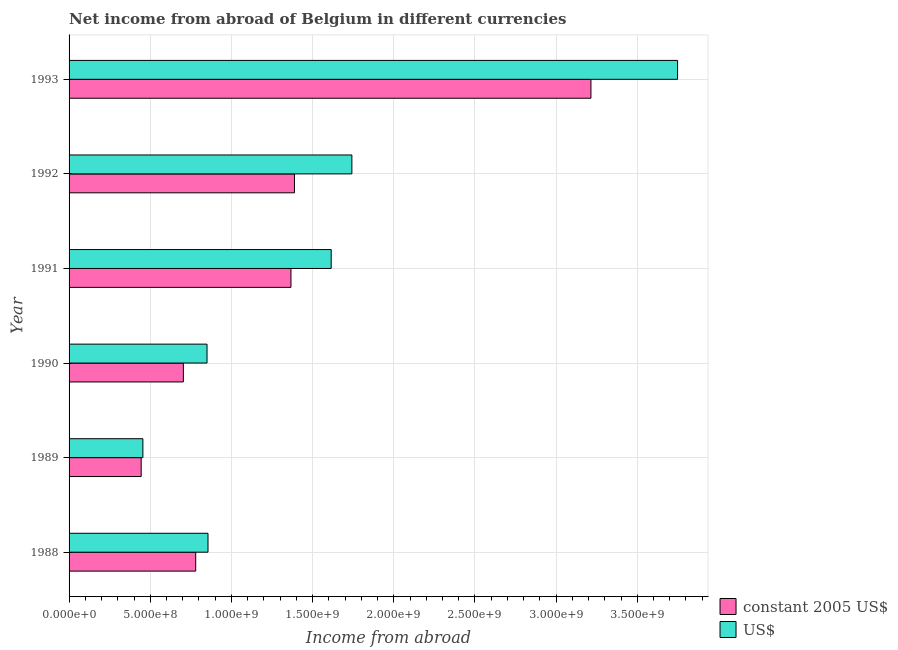How many groups of bars are there?
Ensure brevity in your answer.  6. Are the number of bars per tick equal to the number of legend labels?
Ensure brevity in your answer.  Yes. Are the number of bars on each tick of the Y-axis equal?
Make the answer very short. Yes. How many bars are there on the 1st tick from the bottom?
Provide a short and direct response. 2. What is the label of the 6th group of bars from the top?
Offer a very short reply. 1988. In how many cases, is the number of bars for a given year not equal to the number of legend labels?
Your response must be concise. 0. What is the income from abroad in constant 2005 us$ in 1993?
Make the answer very short. 3.21e+09. Across all years, what is the maximum income from abroad in us$?
Your answer should be very brief. 3.75e+09. Across all years, what is the minimum income from abroad in constant 2005 us$?
Offer a terse response. 4.44e+08. In which year was the income from abroad in us$ maximum?
Ensure brevity in your answer.  1993. In which year was the income from abroad in constant 2005 us$ minimum?
Keep it short and to the point. 1989. What is the total income from abroad in us$ in the graph?
Your answer should be compact. 9.26e+09. What is the difference between the income from abroad in us$ in 1992 and that in 1993?
Make the answer very short. -2.01e+09. What is the difference between the income from abroad in constant 2005 us$ in 1991 and the income from abroad in us$ in 1989?
Your answer should be compact. 9.12e+08. What is the average income from abroad in constant 2005 us$ per year?
Your answer should be compact. 1.32e+09. In the year 1992, what is the difference between the income from abroad in us$ and income from abroad in constant 2005 us$?
Give a very brief answer. 3.54e+08. In how many years, is the income from abroad in constant 2005 us$ greater than 2100000000 units?
Offer a very short reply. 1. What is the ratio of the income from abroad in constant 2005 us$ in 1989 to that in 1990?
Keep it short and to the point. 0.63. What is the difference between the highest and the second highest income from abroad in constant 2005 us$?
Give a very brief answer. 1.83e+09. What is the difference between the highest and the lowest income from abroad in constant 2005 us$?
Ensure brevity in your answer.  2.77e+09. Is the sum of the income from abroad in constant 2005 us$ in 1991 and 1993 greater than the maximum income from abroad in us$ across all years?
Provide a succinct answer. Yes. What does the 1st bar from the top in 1992 represents?
Provide a short and direct response. US$. What does the 1st bar from the bottom in 1989 represents?
Your answer should be very brief. Constant 2005 us$. How many bars are there?
Give a very brief answer. 12. Are all the bars in the graph horizontal?
Provide a short and direct response. Yes. Are the values on the major ticks of X-axis written in scientific E-notation?
Offer a very short reply. Yes. What is the title of the graph?
Offer a very short reply. Net income from abroad of Belgium in different currencies. Does "Short-term debt" appear as one of the legend labels in the graph?
Offer a very short reply. No. What is the label or title of the X-axis?
Provide a short and direct response. Income from abroad. What is the label or title of the Y-axis?
Give a very brief answer. Year. What is the Income from abroad in constant 2005 US$ in 1988?
Ensure brevity in your answer.  7.80e+08. What is the Income from abroad of US$ in 1988?
Give a very brief answer. 8.56e+08. What is the Income from abroad in constant 2005 US$ in 1989?
Offer a very short reply. 4.44e+08. What is the Income from abroad in US$ in 1989?
Keep it short and to the point. 4.55e+08. What is the Income from abroad of constant 2005 US$ in 1990?
Give a very brief answer. 7.04e+08. What is the Income from abroad in US$ in 1990?
Offer a very short reply. 8.50e+08. What is the Income from abroad of constant 2005 US$ in 1991?
Offer a very short reply. 1.37e+09. What is the Income from abroad of US$ in 1991?
Provide a short and direct response. 1.61e+09. What is the Income from abroad of constant 2005 US$ in 1992?
Keep it short and to the point. 1.39e+09. What is the Income from abroad in US$ in 1992?
Offer a terse response. 1.74e+09. What is the Income from abroad in constant 2005 US$ in 1993?
Ensure brevity in your answer.  3.21e+09. What is the Income from abroad of US$ in 1993?
Keep it short and to the point. 3.75e+09. Across all years, what is the maximum Income from abroad in constant 2005 US$?
Your answer should be very brief. 3.21e+09. Across all years, what is the maximum Income from abroad in US$?
Offer a terse response. 3.75e+09. Across all years, what is the minimum Income from abroad in constant 2005 US$?
Keep it short and to the point. 4.44e+08. Across all years, what is the minimum Income from abroad of US$?
Offer a terse response. 4.55e+08. What is the total Income from abroad in constant 2005 US$ in the graph?
Offer a terse response. 7.90e+09. What is the total Income from abroad of US$ in the graph?
Make the answer very short. 9.26e+09. What is the difference between the Income from abroad in constant 2005 US$ in 1988 and that in 1989?
Provide a succinct answer. 3.36e+08. What is the difference between the Income from abroad in US$ in 1988 and that in 1989?
Your answer should be very brief. 4.01e+08. What is the difference between the Income from abroad in constant 2005 US$ in 1988 and that in 1990?
Keep it short and to the point. 7.61e+07. What is the difference between the Income from abroad in US$ in 1988 and that in 1990?
Your response must be concise. 5.97e+06. What is the difference between the Income from abroad of constant 2005 US$ in 1988 and that in 1991?
Provide a succinct answer. -5.87e+08. What is the difference between the Income from abroad in US$ in 1988 and that in 1991?
Provide a short and direct response. -7.59e+08. What is the difference between the Income from abroad in constant 2005 US$ in 1988 and that in 1992?
Your response must be concise. -6.08e+08. What is the difference between the Income from abroad in US$ in 1988 and that in 1992?
Your answer should be very brief. -8.86e+08. What is the difference between the Income from abroad in constant 2005 US$ in 1988 and that in 1993?
Keep it short and to the point. -2.43e+09. What is the difference between the Income from abroad in US$ in 1988 and that in 1993?
Provide a short and direct response. -2.89e+09. What is the difference between the Income from abroad of constant 2005 US$ in 1989 and that in 1990?
Offer a very short reply. -2.60e+08. What is the difference between the Income from abroad in US$ in 1989 and that in 1990?
Your answer should be very brief. -3.95e+08. What is the difference between the Income from abroad of constant 2005 US$ in 1989 and that in 1991?
Provide a short and direct response. -9.23e+08. What is the difference between the Income from abroad in US$ in 1989 and that in 1991?
Your answer should be very brief. -1.16e+09. What is the difference between the Income from abroad in constant 2005 US$ in 1989 and that in 1992?
Ensure brevity in your answer.  -9.44e+08. What is the difference between the Income from abroad of US$ in 1989 and that in 1992?
Offer a very short reply. -1.29e+09. What is the difference between the Income from abroad in constant 2005 US$ in 1989 and that in 1993?
Your answer should be very brief. -2.77e+09. What is the difference between the Income from abroad of US$ in 1989 and that in 1993?
Give a very brief answer. -3.29e+09. What is the difference between the Income from abroad in constant 2005 US$ in 1990 and that in 1991?
Provide a short and direct response. -6.63e+08. What is the difference between the Income from abroad of US$ in 1990 and that in 1991?
Provide a short and direct response. -7.65e+08. What is the difference between the Income from abroad in constant 2005 US$ in 1990 and that in 1992?
Keep it short and to the point. -6.84e+08. What is the difference between the Income from abroad of US$ in 1990 and that in 1992?
Offer a very short reply. -8.92e+08. What is the difference between the Income from abroad of constant 2005 US$ in 1990 and that in 1993?
Give a very brief answer. -2.51e+09. What is the difference between the Income from abroad in US$ in 1990 and that in 1993?
Your answer should be compact. -2.90e+09. What is the difference between the Income from abroad of constant 2005 US$ in 1991 and that in 1992?
Make the answer very short. -2.17e+07. What is the difference between the Income from abroad in US$ in 1991 and that in 1992?
Your answer should be very brief. -1.27e+08. What is the difference between the Income from abroad of constant 2005 US$ in 1991 and that in 1993?
Ensure brevity in your answer.  -1.85e+09. What is the difference between the Income from abroad in US$ in 1991 and that in 1993?
Offer a very short reply. -2.13e+09. What is the difference between the Income from abroad in constant 2005 US$ in 1992 and that in 1993?
Ensure brevity in your answer.  -1.83e+09. What is the difference between the Income from abroad of US$ in 1992 and that in 1993?
Give a very brief answer. -2.01e+09. What is the difference between the Income from abroad in constant 2005 US$ in 1988 and the Income from abroad in US$ in 1989?
Give a very brief answer. 3.25e+08. What is the difference between the Income from abroad of constant 2005 US$ in 1988 and the Income from abroad of US$ in 1990?
Give a very brief answer. -6.98e+07. What is the difference between the Income from abroad in constant 2005 US$ in 1988 and the Income from abroad in US$ in 1991?
Give a very brief answer. -8.34e+08. What is the difference between the Income from abroad in constant 2005 US$ in 1988 and the Income from abroad in US$ in 1992?
Offer a terse response. -9.62e+08. What is the difference between the Income from abroad in constant 2005 US$ in 1988 and the Income from abroad in US$ in 1993?
Give a very brief answer. -2.97e+09. What is the difference between the Income from abroad in constant 2005 US$ in 1989 and the Income from abroad in US$ in 1990?
Give a very brief answer. -4.06e+08. What is the difference between the Income from abroad of constant 2005 US$ in 1989 and the Income from abroad of US$ in 1991?
Provide a succinct answer. -1.17e+09. What is the difference between the Income from abroad of constant 2005 US$ in 1989 and the Income from abroad of US$ in 1992?
Offer a terse response. -1.30e+09. What is the difference between the Income from abroad of constant 2005 US$ in 1989 and the Income from abroad of US$ in 1993?
Provide a succinct answer. -3.30e+09. What is the difference between the Income from abroad in constant 2005 US$ in 1990 and the Income from abroad in US$ in 1991?
Make the answer very short. -9.11e+08. What is the difference between the Income from abroad in constant 2005 US$ in 1990 and the Income from abroad in US$ in 1992?
Keep it short and to the point. -1.04e+09. What is the difference between the Income from abroad of constant 2005 US$ in 1990 and the Income from abroad of US$ in 1993?
Give a very brief answer. -3.04e+09. What is the difference between the Income from abroad in constant 2005 US$ in 1991 and the Income from abroad in US$ in 1992?
Provide a short and direct response. -3.75e+08. What is the difference between the Income from abroad in constant 2005 US$ in 1991 and the Income from abroad in US$ in 1993?
Keep it short and to the point. -2.38e+09. What is the difference between the Income from abroad in constant 2005 US$ in 1992 and the Income from abroad in US$ in 1993?
Give a very brief answer. -2.36e+09. What is the average Income from abroad in constant 2005 US$ per year?
Offer a terse response. 1.32e+09. What is the average Income from abroad in US$ per year?
Make the answer very short. 1.54e+09. In the year 1988, what is the difference between the Income from abroad in constant 2005 US$ and Income from abroad in US$?
Keep it short and to the point. -7.57e+07. In the year 1989, what is the difference between the Income from abroad in constant 2005 US$ and Income from abroad in US$?
Offer a very short reply. -1.05e+07. In the year 1990, what is the difference between the Income from abroad in constant 2005 US$ and Income from abroad in US$?
Ensure brevity in your answer.  -1.46e+08. In the year 1991, what is the difference between the Income from abroad in constant 2005 US$ and Income from abroad in US$?
Your response must be concise. -2.48e+08. In the year 1992, what is the difference between the Income from abroad in constant 2005 US$ and Income from abroad in US$?
Offer a terse response. -3.54e+08. In the year 1993, what is the difference between the Income from abroad of constant 2005 US$ and Income from abroad of US$?
Your response must be concise. -5.34e+08. What is the ratio of the Income from abroad in constant 2005 US$ in 1988 to that in 1989?
Provide a succinct answer. 1.76. What is the ratio of the Income from abroad of US$ in 1988 to that in 1989?
Provide a succinct answer. 1.88. What is the ratio of the Income from abroad of constant 2005 US$ in 1988 to that in 1990?
Provide a succinct answer. 1.11. What is the ratio of the Income from abroad in US$ in 1988 to that in 1990?
Your answer should be compact. 1.01. What is the ratio of the Income from abroad of constant 2005 US$ in 1988 to that in 1991?
Your answer should be very brief. 0.57. What is the ratio of the Income from abroad in US$ in 1988 to that in 1991?
Give a very brief answer. 0.53. What is the ratio of the Income from abroad of constant 2005 US$ in 1988 to that in 1992?
Offer a terse response. 0.56. What is the ratio of the Income from abroad in US$ in 1988 to that in 1992?
Your response must be concise. 0.49. What is the ratio of the Income from abroad of constant 2005 US$ in 1988 to that in 1993?
Your response must be concise. 0.24. What is the ratio of the Income from abroad of US$ in 1988 to that in 1993?
Offer a very short reply. 0.23. What is the ratio of the Income from abroad of constant 2005 US$ in 1989 to that in 1990?
Give a very brief answer. 0.63. What is the ratio of the Income from abroad in US$ in 1989 to that in 1990?
Your answer should be compact. 0.54. What is the ratio of the Income from abroad of constant 2005 US$ in 1989 to that in 1991?
Your answer should be very brief. 0.33. What is the ratio of the Income from abroad in US$ in 1989 to that in 1991?
Keep it short and to the point. 0.28. What is the ratio of the Income from abroad of constant 2005 US$ in 1989 to that in 1992?
Keep it short and to the point. 0.32. What is the ratio of the Income from abroad of US$ in 1989 to that in 1992?
Make the answer very short. 0.26. What is the ratio of the Income from abroad of constant 2005 US$ in 1989 to that in 1993?
Your response must be concise. 0.14. What is the ratio of the Income from abroad in US$ in 1989 to that in 1993?
Your answer should be very brief. 0.12. What is the ratio of the Income from abroad in constant 2005 US$ in 1990 to that in 1991?
Your response must be concise. 0.52. What is the ratio of the Income from abroad in US$ in 1990 to that in 1991?
Your answer should be compact. 0.53. What is the ratio of the Income from abroad in constant 2005 US$ in 1990 to that in 1992?
Keep it short and to the point. 0.51. What is the ratio of the Income from abroad in US$ in 1990 to that in 1992?
Provide a succinct answer. 0.49. What is the ratio of the Income from abroad of constant 2005 US$ in 1990 to that in 1993?
Give a very brief answer. 0.22. What is the ratio of the Income from abroad in US$ in 1990 to that in 1993?
Make the answer very short. 0.23. What is the ratio of the Income from abroad in constant 2005 US$ in 1991 to that in 1992?
Give a very brief answer. 0.98. What is the ratio of the Income from abroad in US$ in 1991 to that in 1992?
Offer a terse response. 0.93. What is the ratio of the Income from abroad of constant 2005 US$ in 1991 to that in 1993?
Your response must be concise. 0.43. What is the ratio of the Income from abroad of US$ in 1991 to that in 1993?
Offer a very short reply. 0.43. What is the ratio of the Income from abroad of constant 2005 US$ in 1992 to that in 1993?
Make the answer very short. 0.43. What is the ratio of the Income from abroad of US$ in 1992 to that in 1993?
Your response must be concise. 0.46. What is the difference between the highest and the second highest Income from abroad in constant 2005 US$?
Keep it short and to the point. 1.83e+09. What is the difference between the highest and the second highest Income from abroad of US$?
Your answer should be compact. 2.01e+09. What is the difference between the highest and the lowest Income from abroad of constant 2005 US$?
Provide a succinct answer. 2.77e+09. What is the difference between the highest and the lowest Income from abroad in US$?
Provide a succinct answer. 3.29e+09. 